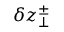Convert formula to latex. <formula><loc_0><loc_0><loc_500><loc_500>\delta z _ { \perp } ^ { \pm }</formula> 